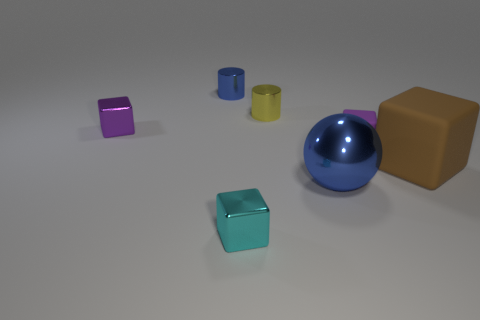Subtract all tiny purple rubber cubes. How many cubes are left? 3 Subtract all yellow cylinders. How many purple cubes are left? 2 Subtract 2 blocks. How many blocks are left? 2 Subtract all brown cubes. How many cubes are left? 3 Add 2 gray metallic cylinders. How many objects exist? 9 Subtract all cylinders. How many objects are left? 5 Subtract all brown cylinders. Subtract all purple cubes. How many cylinders are left? 2 Add 4 tiny cyan metal objects. How many tiny cyan metal objects are left? 5 Add 2 yellow balls. How many yellow balls exist? 2 Subtract 0 gray balls. How many objects are left? 7 